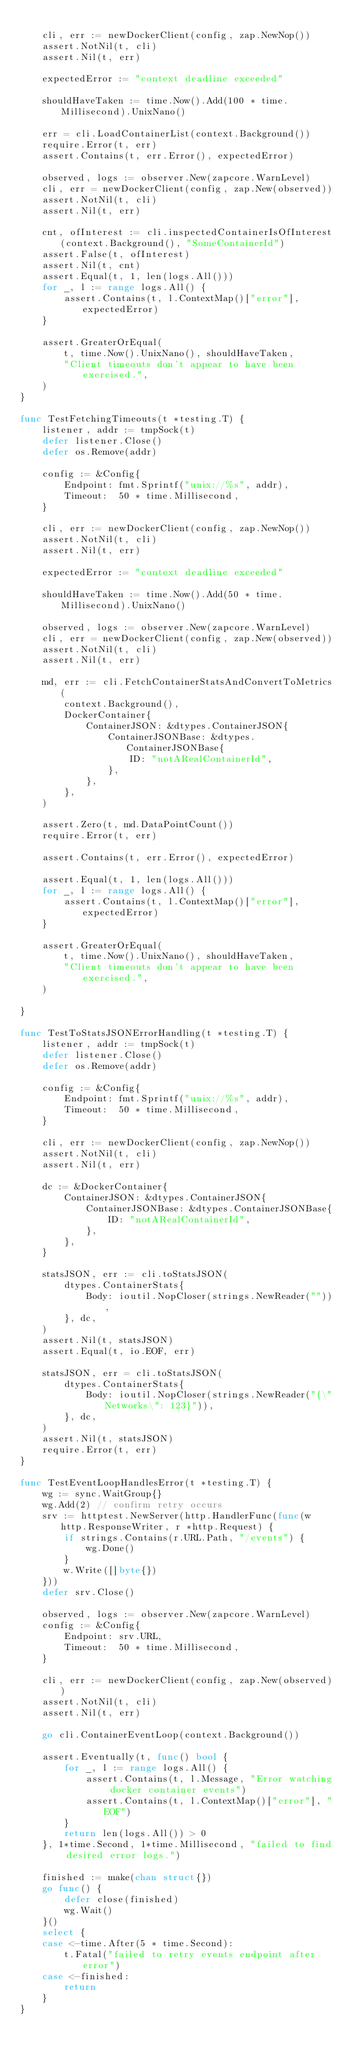<code> <loc_0><loc_0><loc_500><loc_500><_Go_>
	cli, err := newDockerClient(config, zap.NewNop())
	assert.NotNil(t, cli)
	assert.Nil(t, err)

	expectedError := "context deadline exceeded"

	shouldHaveTaken := time.Now().Add(100 * time.Millisecond).UnixNano()

	err = cli.LoadContainerList(context.Background())
	require.Error(t, err)
	assert.Contains(t, err.Error(), expectedError)

	observed, logs := observer.New(zapcore.WarnLevel)
	cli, err = newDockerClient(config, zap.New(observed))
	assert.NotNil(t, cli)
	assert.Nil(t, err)

	cnt, ofInterest := cli.inspectedContainerIsOfInterest(context.Background(), "SomeContainerId")
	assert.False(t, ofInterest)
	assert.Nil(t, cnt)
	assert.Equal(t, 1, len(logs.All()))
	for _, l := range logs.All() {
		assert.Contains(t, l.ContextMap()["error"], expectedError)
	}

	assert.GreaterOrEqual(
		t, time.Now().UnixNano(), shouldHaveTaken,
		"Client timeouts don't appear to have been exercised.",
	)
}

func TestFetchingTimeouts(t *testing.T) {
	listener, addr := tmpSock(t)
	defer listener.Close()
	defer os.Remove(addr)

	config := &Config{
		Endpoint: fmt.Sprintf("unix://%s", addr),
		Timeout:  50 * time.Millisecond,
	}

	cli, err := newDockerClient(config, zap.NewNop())
	assert.NotNil(t, cli)
	assert.Nil(t, err)

	expectedError := "context deadline exceeded"

	shouldHaveTaken := time.Now().Add(50 * time.Millisecond).UnixNano()

	observed, logs := observer.New(zapcore.WarnLevel)
	cli, err = newDockerClient(config, zap.New(observed))
	assert.NotNil(t, cli)
	assert.Nil(t, err)

	md, err := cli.FetchContainerStatsAndConvertToMetrics(
		context.Background(),
		DockerContainer{
			ContainerJSON: &dtypes.ContainerJSON{
				ContainerJSONBase: &dtypes.ContainerJSONBase{
					ID: "notARealContainerId",
				},
			},
		},
	)

	assert.Zero(t, md.DataPointCount())
	require.Error(t, err)

	assert.Contains(t, err.Error(), expectedError)

	assert.Equal(t, 1, len(logs.All()))
	for _, l := range logs.All() {
		assert.Contains(t, l.ContextMap()["error"], expectedError)
	}

	assert.GreaterOrEqual(
		t, time.Now().UnixNano(), shouldHaveTaken,
		"Client timeouts don't appear to have been exercised.",
	)

}

func TestToStatsJSONErrorHandling(t *testing.T) {
	listener, addr := tmpSock(t)
	defer listener.Close()
	defer os.Remove(addr)

	config := &Config{
		Endpoint: fmt.Sprintf("unix://%s", addr),
		Timeout:  50 * time.Millisecond,
	}

	cli, err := newDockerClient(config, zap.NewNop())
	assert.NotNil(t, cli)
	assert.Nil(t, err)

	dc := &DockerContainer{
		ContainerJSON: &dtypes.ContainerJSON{
			ContainerJSONBase: &dtypes.ContainerJSONBase{
				ID: "notARealContainerId",
			},
		},
	}

	statsJSON, err := cli.toStatsJSON(
		dtypes.ContainerStats{
			Body: ioutil.NopCloser(strings.NewReader("")),
		}, dc,
	)
	assert.Nil(t, statsJSON)
	assert.Equal(t, io.EOF, err)

	statsJSON, err = cli.toStatsJSON(
		dtypes.ContainerStats{
			Body: ioutil.NopCloser(strings.NewReader("{\"Networks\": 123}")),
		}, dc,
	)
	assert.Nil(t, statsJSON)
	require.Error(t, err)
}

func TestEventLoopHandlesError(t *testing.T) {
	wg := sync.WaitGroup{}
	wg.Add(2) // confirm retry occurs
	srv := httptest.NewServer(http.HandlerFunc(func(w http.ResponseWriter, r *http.Request) {
		if strings.Contains(r.URL.Path, "/events") {
			wg.Done()
		}
		w.Write([]byte{})
	}))
	defer srv.Close()

	observed, logs := observer.New(zapcore.WarnLevel)
	config := &Config{
		Endpoint: srv.URL,
		Timeout:  50 * time.Millisecond,
	}

	cli, err := newDockerClient(config, zap.New(observed))
	assert.NotNil(t, cli)
	assert.Nil(t, err)

	go cli.ContainerEventLoop(context.Background())

	assert.Eventually(t, func() bool {
		for _, l := range logs.All() {
			assert.Contains(t, l.Message, "Error watching docker container events")
			assert.Contains(t, l.ContextMap()["error"], "EOF")
		}
		return len(logs.All()) > 0
	}, 1*time.Second, 1*time.Millisecond, "failed to find desired error logs.")

	finished := make(chan struct{})
	go func() {
		defer close(finished)
		wg.Wait()
	}()
	select {
	case <-time.After(5 * time.Second):
		t.Fatal("failed to retry events endpoint after error")
	case <-finished:
		return
	}
}
</code> 